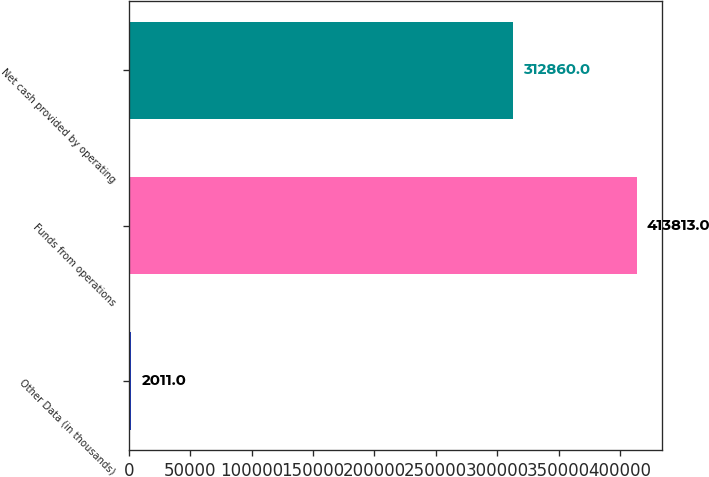<chart> <loc_0><loc_0><loc_500><loc_500><bar_chart><fcel>Other Data (in thousands)<fcel>Funds from operations<fcel>Net cash provided by operating<nl><fcel>2011<fcel>413813<fcel>312860<nl></chart> 